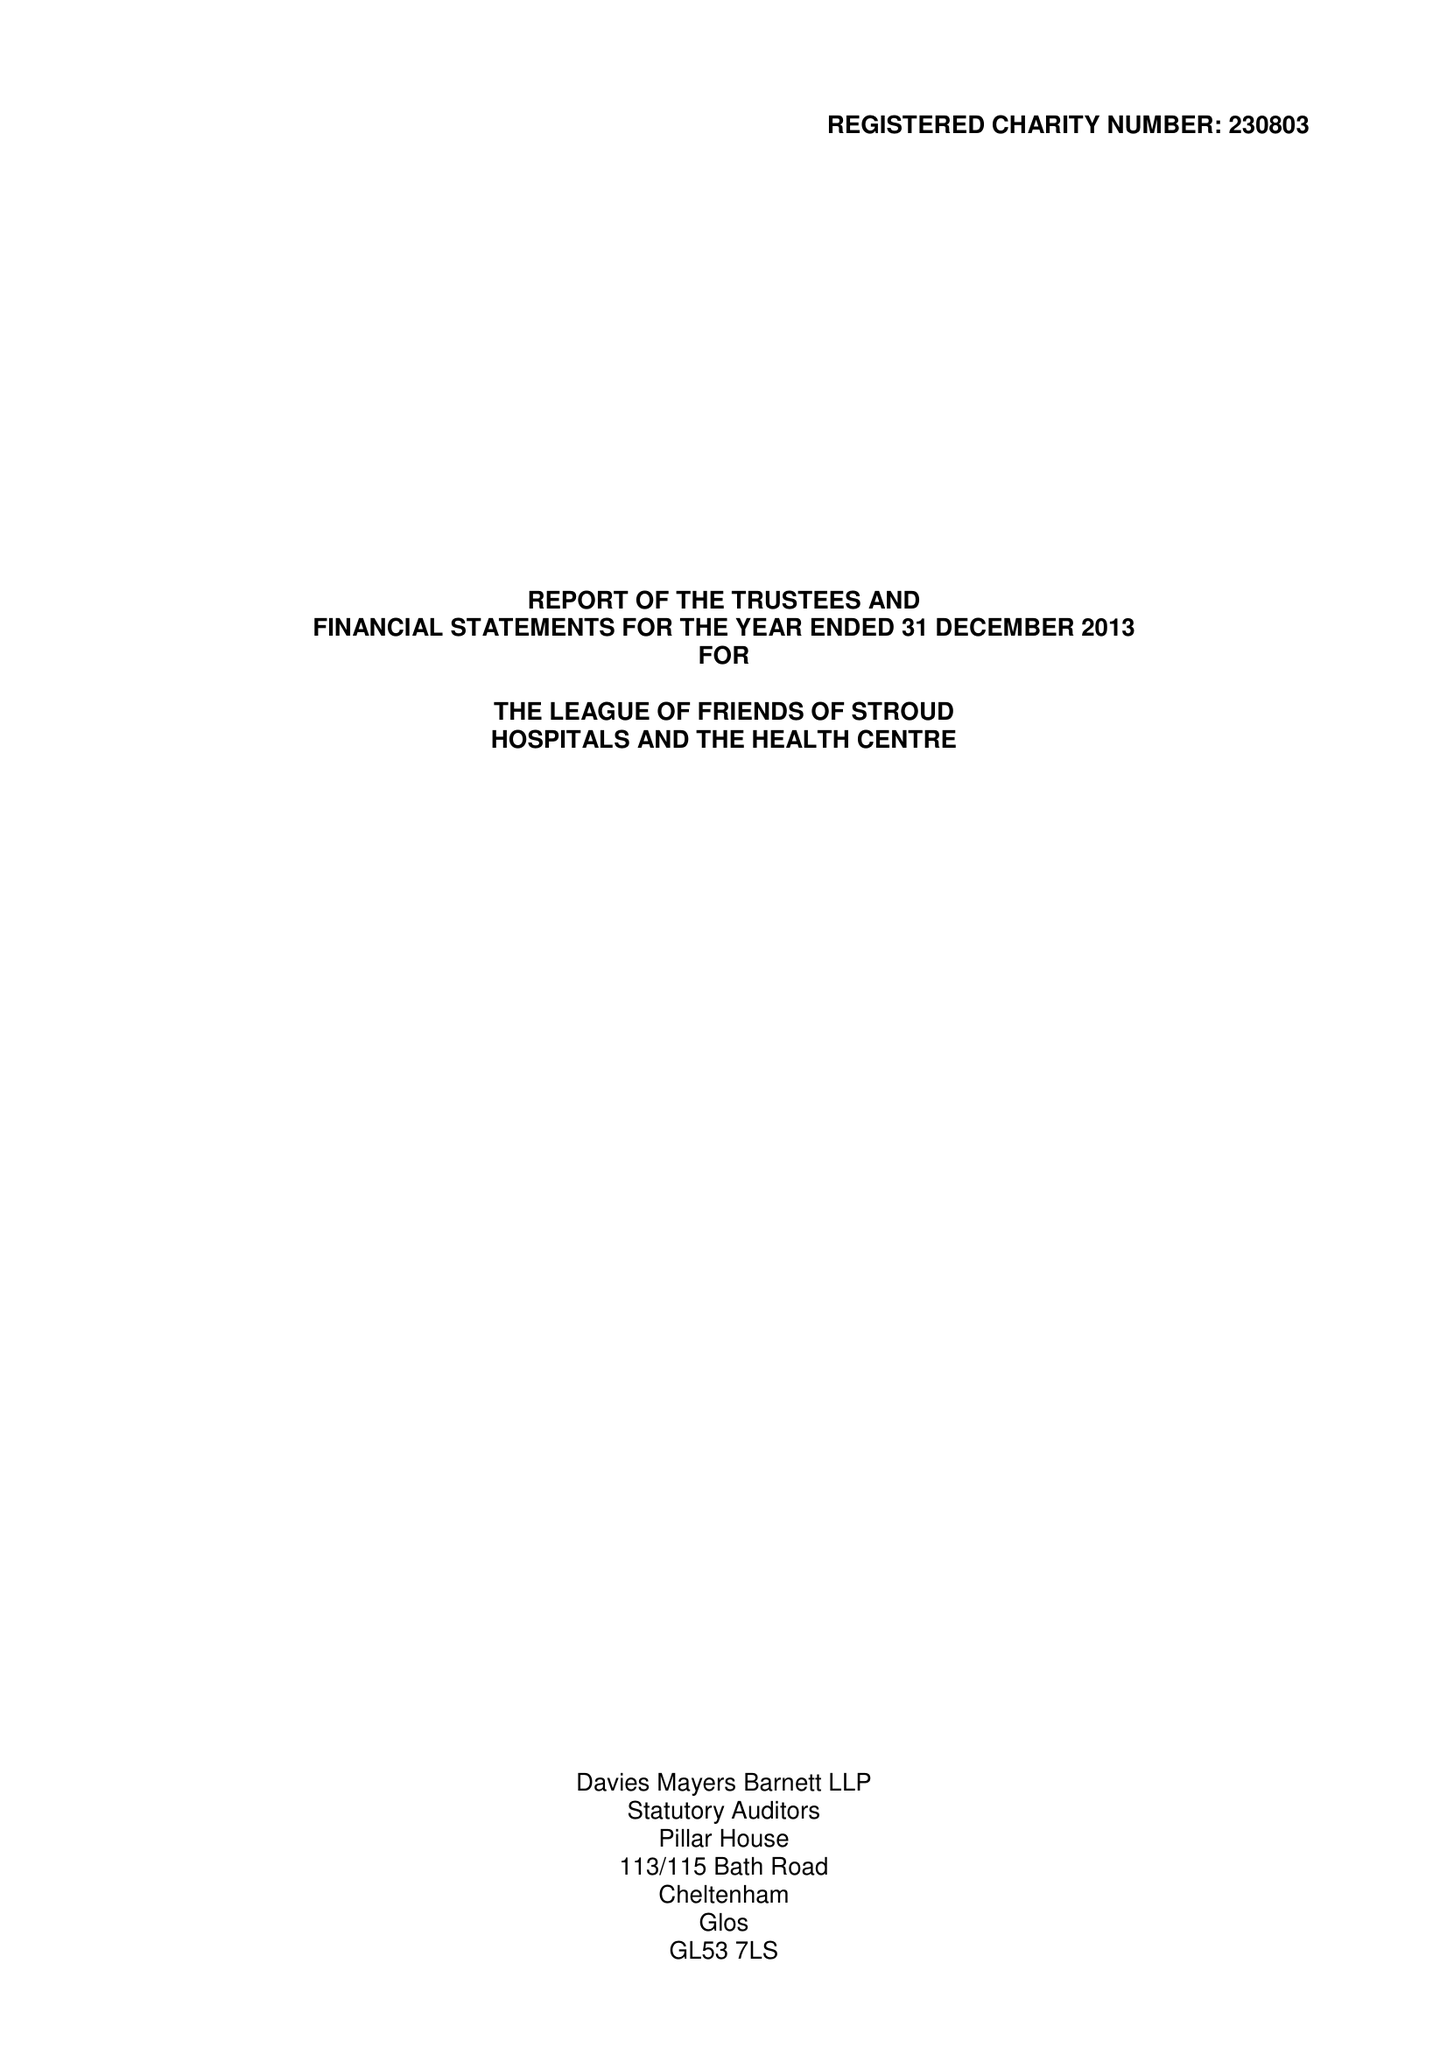What is the value for the charity_number?
Answer the question using a single word or phrase. 230803 